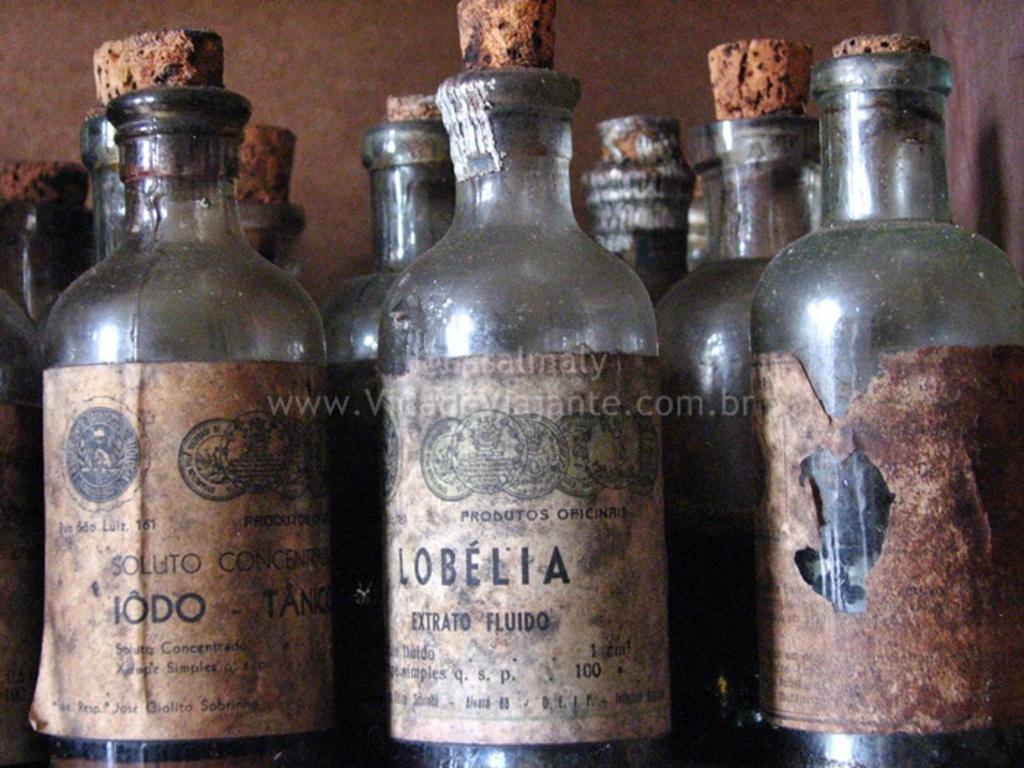How would you summarize this image in a sentence or two? In this image, there are bottles in which chemicals are kept and a lid is there and on that some text is written. In the background there is a wall which is grey in color. It looks as if the image is taken inside a lab. 